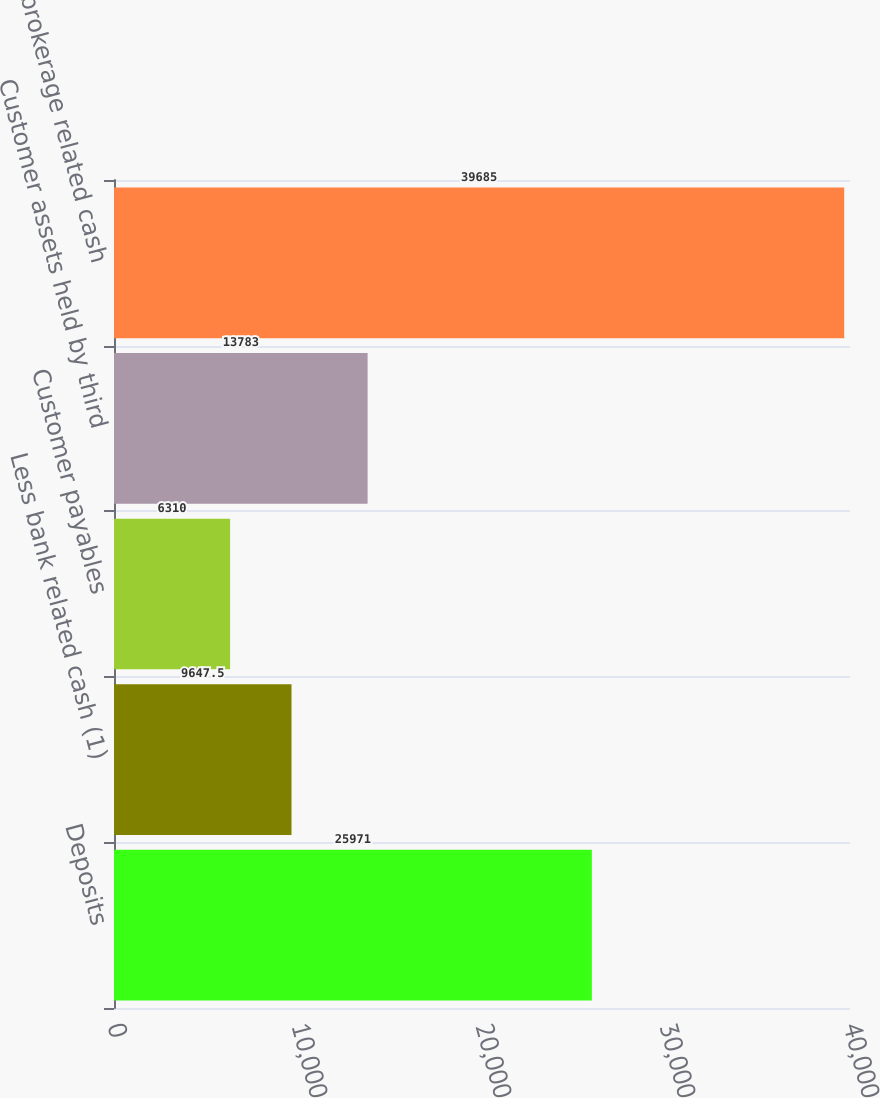<chart> <loc_0><loc_0><loc_500><loc_500><bar_chart><fcel>Deposits<fcel>Less bank related cash (1)<fcel>Customer payables<fcel>Customer assets held by third<fcel>Total brokerage related cash<nl><fcel>25971<fcel>9647.5<fcel>6310<fcel>13783<fcel>39685<nl></chart> 